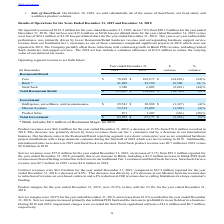From Par Technology's financial document, What was the revenue in 2019 and 2018 respectively? The document shows two values: $187.2 million and $201.2 million. From the document: "r the year ended December 31, 2019, down 7.0% from $201.2 million for the year ended December 31, 2018. Our net loss was $15.6 million or $0.96 loss p..." Also, What was the revenue from Brink in 2019 and 2018 respectively? The document shows two values: 41,689 and 25,189 (in thousands). From the document: "Brink * 41,689 25,189 16,500 66 % Brink * 41,689 25,189 16,500 66 %..." Also, What was the core revenue in 2019 and 2018 respectively? The document shows two values: $78,238 and $102,877 (in thousands). From the document: "Core $ 78,238 $ 102,877 $ (24,639) (24)% Core $ 78,238 $ 102,877 $ (24,639) (24)%..." Also, can you calculate: What is the average Core revenue for 2018 and 2019? To answer this question, I need to perform calculations using the financial data. The calculation is: (78,238 + 102,877) / 2, which equals 90557.5 (in thousands). This is based on the information: "Core $ 78,238 $ 102,877 $ (24,639) (24)% Core $ 78,238 $ 102,877 $ (24,639) (24)%..." The key data points involved are: 102,877, 78,238. Additionally, In which year was Brink revenue less than 40,000 thousands? According to the financial document, 2018. The relevant text states: "(in thousands) 2019 2018 variance variance..." Also, can you calculate: What percentage of total government revenue was from product sales in 2019? Based on the calculation: 871 / 63,925, the result is 1.36 (percentage). This is based on the information: "Total Government $ 63,925 $ 67,177 $ (3,252) (5)% Product Sales 871 1,207 (336) (28)%..." The key data points involved are: 63,925, 871. 